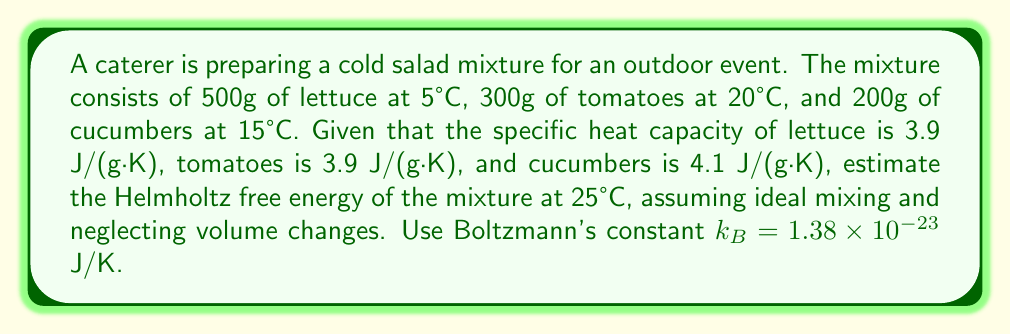Show me your answer to this math problem. To estimate the Helmholtz free energy of the mixture, we'll follow these steps:

1. Calculate the internal energy change (ΔU) for each ingredient:
   ΔU = m · c · ΔT
   
   For lettuce: $\Delta U_l = 500 \cdot 3.9 \cdot (25-5) = 39000$ J
   For tomatoes: $\Delta U_t = 300 \cdot 3.9 \cdot (25-20) = 5850$ J
   For cucumbers: $\Delta U_c = 200 \cdot 4.1 \cdot (25-15) = 8200$ J
   
   Total ΔU = 39000 + 5850 + 8200 = 53050 J

2. Calculate the entropy change (ΔS) for each ingredient:
   ΔS = m · c · ln(T_f / T_i)
   
   For lettuce: $\Delta S_l = 500 \cdot 3.9 \cdot \ln(298/278) = 136.87$ J/K
   For tomatoes: $\Delta S_t = 300 \cdot 3.9 \cdot \ln(298/293) = 20.11$ J/K
   For cucumbers: $\Delta S_c = 200 \cdot 4.1 \cdot \ln(298/288) = 28.36$ J/K
   
   Total ΔS = 136.87 + 20.11 + 28.36 = 185.34 J/K

3. Calculate the mixing entropy:
   $\Delta S_{mix} = -k_B \cdot N \cdot \sum x_i \ln x_i$
   where N is the total number of molecules and x_i are the mole fractions

   Approximate mole fractions:
   x_l = 500/(500+300+200) = 0.5
   x_t = 300/(500+300+200) = 0.3
   x_c = 200/(500+300+200) = 0.2

   $\Delta S_{mix} = -1.38 \times 10^{-23} \cdot (1000/0.018) \cdot (0.5\ln0.5 + 0.3\ln0.3 + 0.2\ln0.2)$
   $\Delta S_{mix} = 0.94$ J/K

4. Calculate the Helmholtz free energy:
   $\Delta F = \Delta U - T\Delta S_{total}$
   where $\Delta S_{total} = \Delta S + \Delta S_{mix}$

   $\Delta F = 53050 - 298 \cdot (185.34 + 0.94)$
   $\Delta F = 53050 - 55472.36$
   $\Delta F = -2422.36$ J

Therefore, the estimated Helmholtz free energy of the mixture is -2422.36 J.
Answer: -2422.36 J 